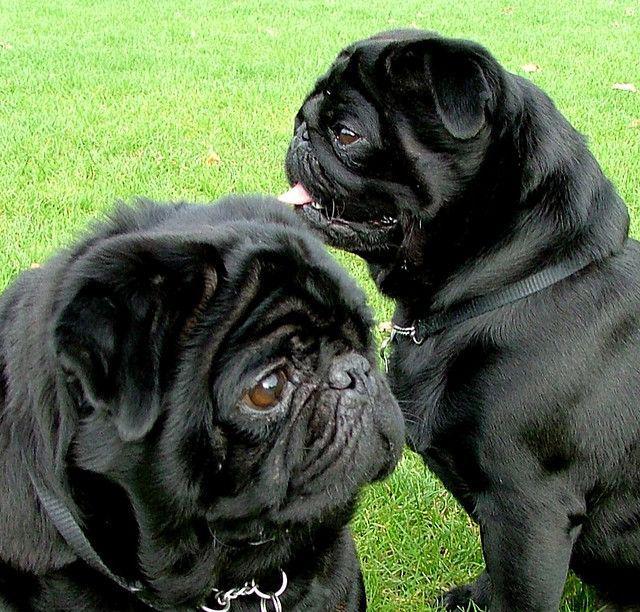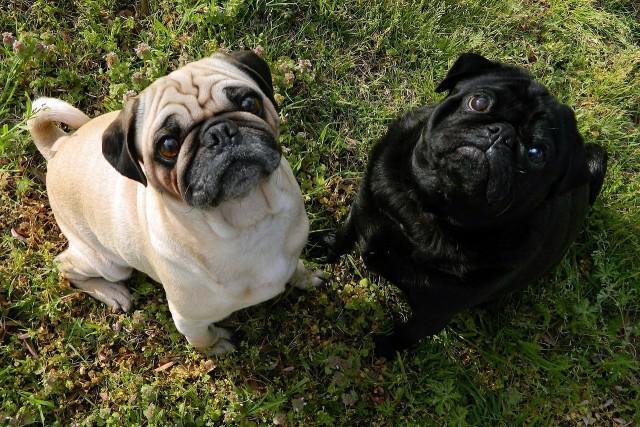The first image is the image on the left, the second image is the image on the right. For the images shown, is this caption "There is a toy present with two dogs." true? Answer yes or no. No. The first image is the image on the left, the second image is the image on the right. Given the left and right images, does the statement "All the images show pugs that are tan." hold true? Answer yes or no. No. 